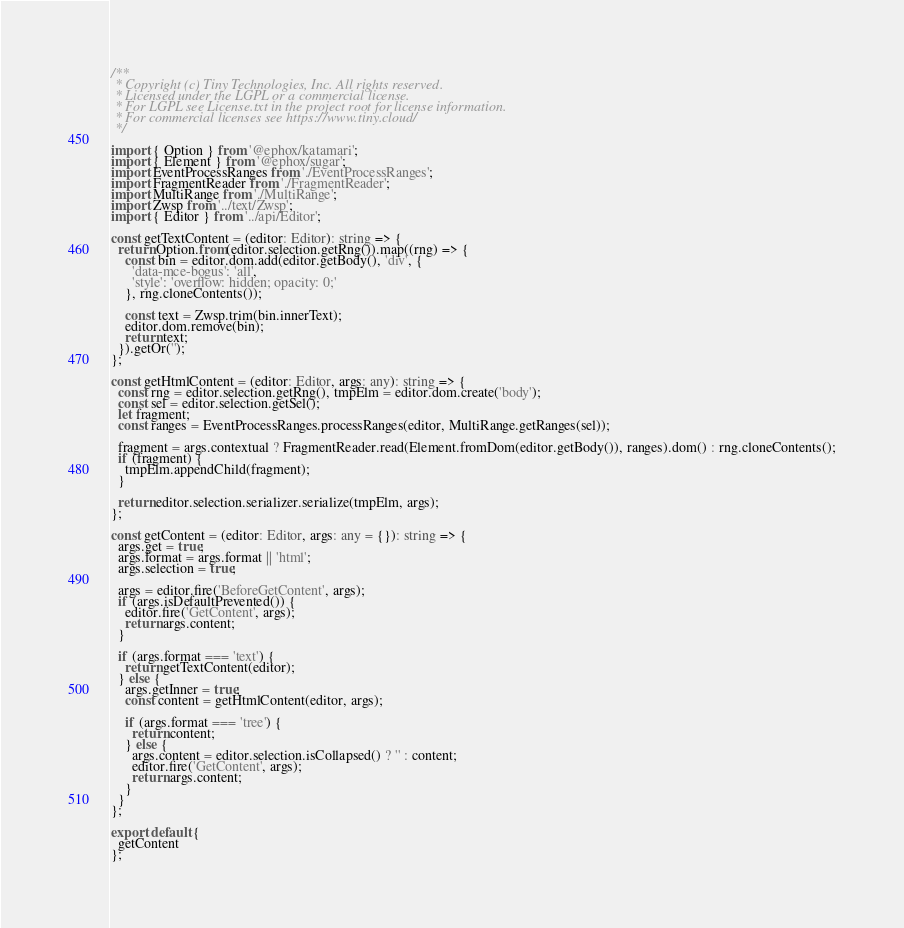Convert code to text. <code><loc_0><loc_0><loc_500><loc_500><_TypeScript_>/**
 * Copyright (c) Tiny Technologies, Inc. All rights reserved.
 * Licensed under the LGPL or a commercial license.
 * For LGPL see License.txt in the project root for license information.
 * For commercial licenses see https://www.tiny.cloud/
 */

import { Option } from '@ephox/katamari';
import { Element } from '@ephox/sugar';
import EventProcessRanges from './EventProcessRanges';
import FragmentReader from './FragmentReader';
import MultiRange from './MultiRange';
import Zwsp from '../text/Zwsp';
import { Editor } from '../api/Editor';

const getTextContent = (editor: Editor): string => {
  return Option.from(editor.selection.getRng()).map((rng) => {
    const bin = editor.dom.add(editor.getBody(), 'div', {
      'data-mce-bogus': 'all',
      'style': 'overflow: hidden; opacity: 0;'
    }, rng.cloneContents());

    const text = Zwsp.trim(bin.innerText);
    editor.dom.remove(bin);
    return text;
  }).getOr('');
};

const getHtmlContent = (editor: Editor, args: any): string => {
  const rng = editor.selection.getRng(), tmpElm = editor.dom.create('body');
  const sel = editor.selection.getSel();
  let fragment;
  const ranges = EventProcessRanges.processRanges(editor, MultiRange.getRanges(sel));

  fragment = args.contextual ? FragmentReader.read(Element.fromDom(editor.getBody()), ranges).dom() : rng.cloneContents();
  if (fragment) {
    tmpElm.appendChild(fragment);
  }

  return editor.selection.serializer.serialize(tmpElm, args);
};

const getContent = (editor: Editor, args: any = {}): string => {
  args.get = true;
  args.format = args.format || 'html';
  args.selection = true;

  args = editor.fire('BeforeGetContent', args);
  if (args.isDefaultPrevented()) {
    editor.fire('GetContent', args);
    return args.content;
  }

  if (args.format === 'text') {
    return getTextContent(editor);
  } else {
    args.getInner = true;
    const content = getHtmlContent(editor, args);

    if (args.format === 'tree') {
      return content;
    } else {
      args.content = editor.selection.isCollapsed() ? '' : content;
      editor.fire('GetContent', args);
      return args.content;
    }
  }
};

export default {
  getContent
};</code> 